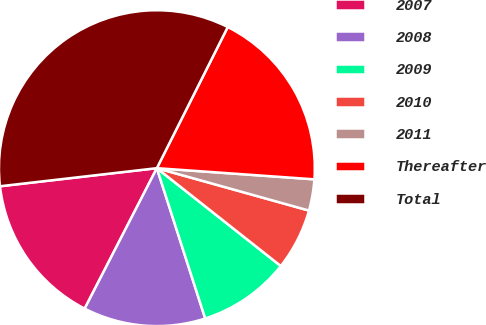Convert chart to OTSL. <chart><loc_0><loc_0><loc_500><loc_500><pie_chart><fcel>2007<fcel>2008<fcel>2009<fcel>2010<fcel>2011<fcel>Thereafter<fcel>Total<nl><fcel>15.62%<fcel>12.51%<fcel>9.41%<fcel>6.31%<fcel>3.2%<fcel>18.72%<fcel>34.24%<nl></chart> 